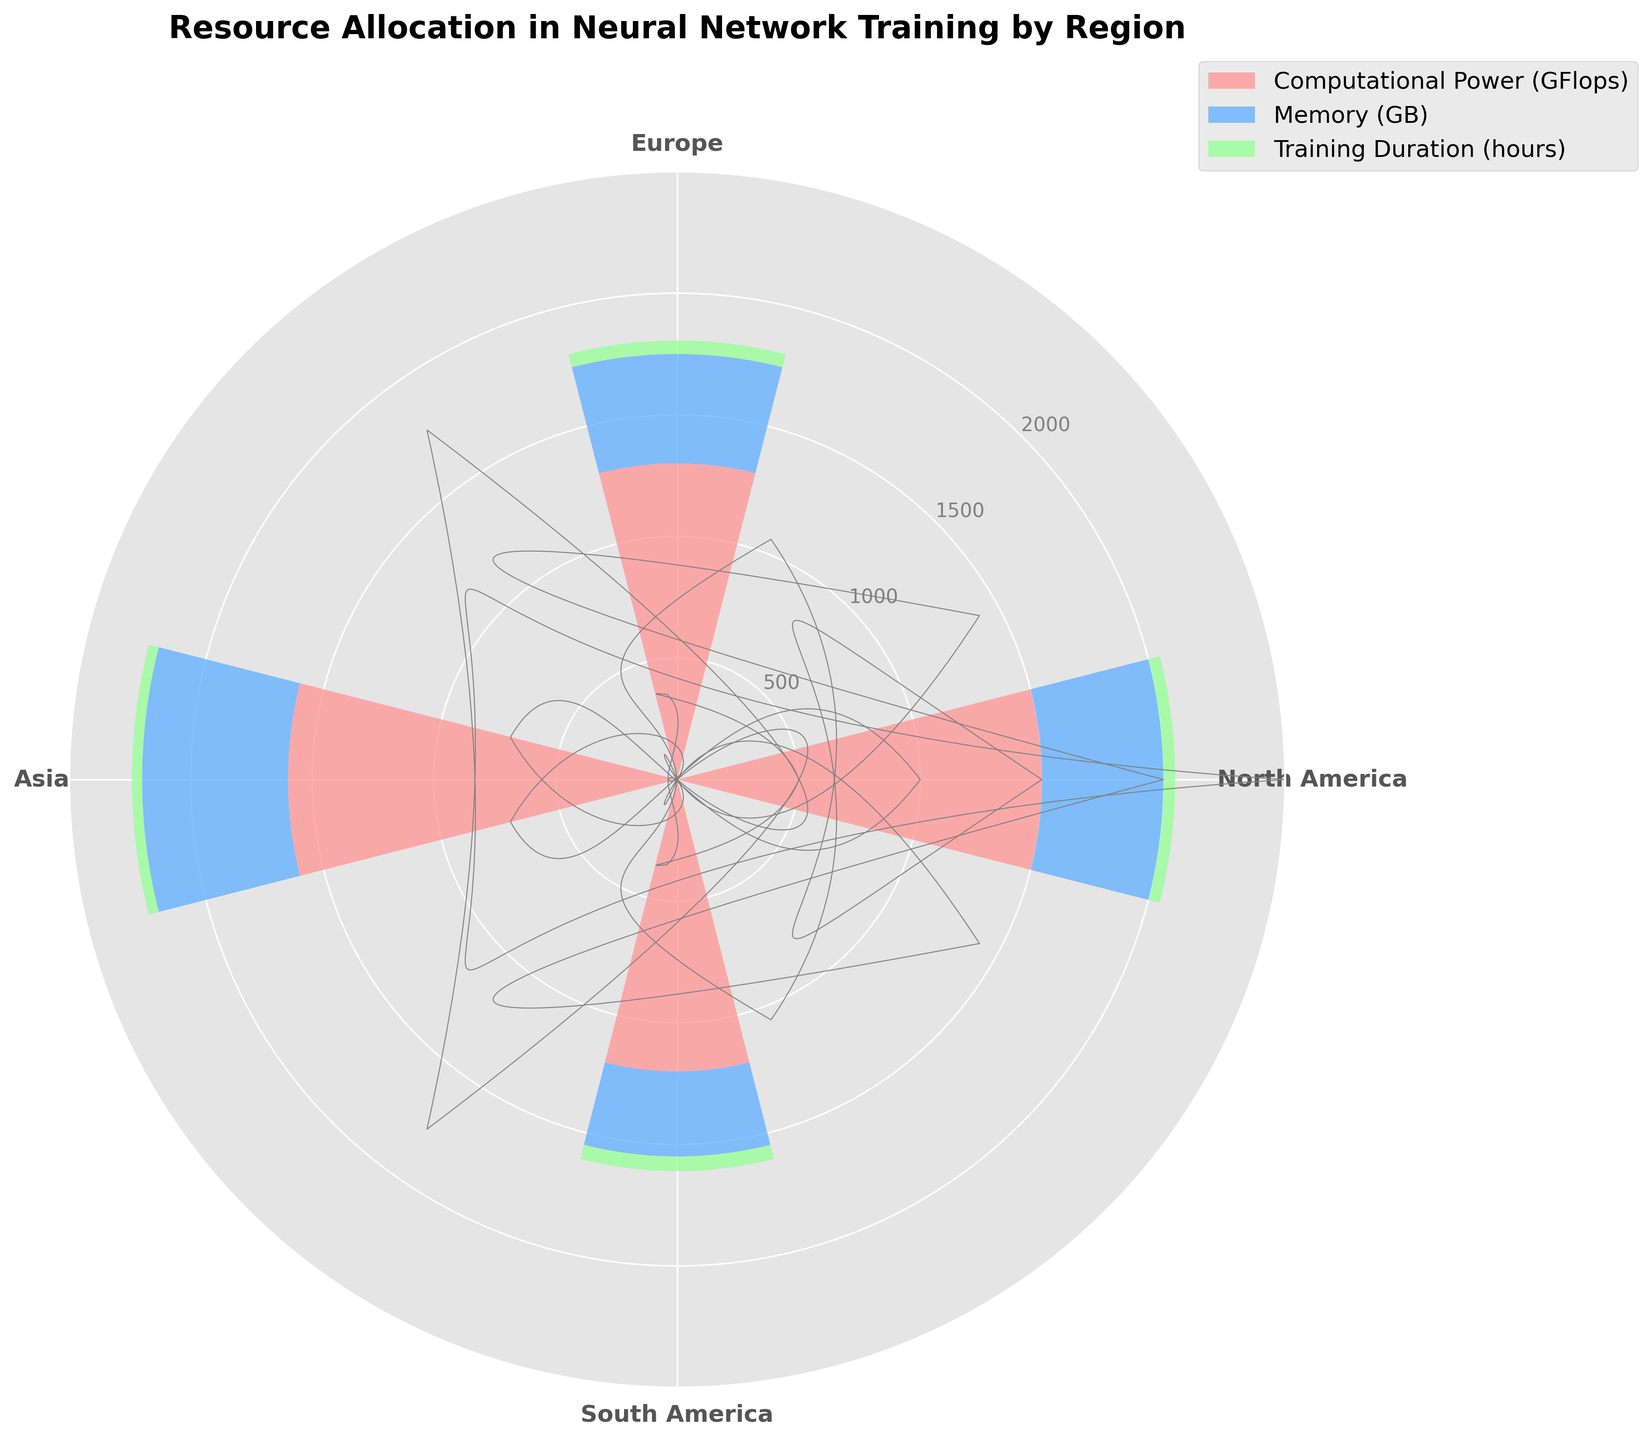which region has the highest computational power? By observing the height of the bars for Computational Power (red bars) in the figure, we can see that Asia has the tallest bar, indicating the highest computational power.
Answer: Asia What is the sum of memory allocation and training duration in South America? First look at the blue bar (Memory) and the green bar (Training Duration) for South America. These bars represent 350 GB and 60 hours, respectively. Adding them together, we get 350 + 60 = 410.
Answer: 410 Which region has the shortest training duration? By examining the height of the green bars representing Training Duration, we can see that Asia has the shortest green bar.
Answer: Asia Which region has more computational power, Europe or North America? Comparing the heights of the red bars for Europe and North America, we find that North America has a higher red bar representing computational power.
Answer: North America What is the average memory allocation across all regions? The memory allocations for all regions are: North America (500 GB), Europe (450 GB), Asia (600 GB), and South America (350 GB). To find the average, we sum them: 500 + 450 + 600 + 350 = 1900 and then divide by 4: 1900 / 4 = 475 GB.
Answer: 475 Is the memory allocation in Asia greater than the sum of computational power in Europe and South America? The memory allocation in Asia is 600 GB. The computational power in Europe is 1300 GFlops and in South America is 1200 GFlops. The sum of Europe and South America's computational power is 1300 + 1200 = 2500 GFlops. Since 600 GB (Memory in Asia) < 2500 GFlops (Sum of computational power in Europe and South America), the condition does not hold.
Answer: No How many regions have a training duration of over 50 hours? Observing the green bars, we can identify that Europe (55 hours) and South America (60 hours) both have training durations over 50 hours. Thus, there are 2 regions.
Answer: 2 